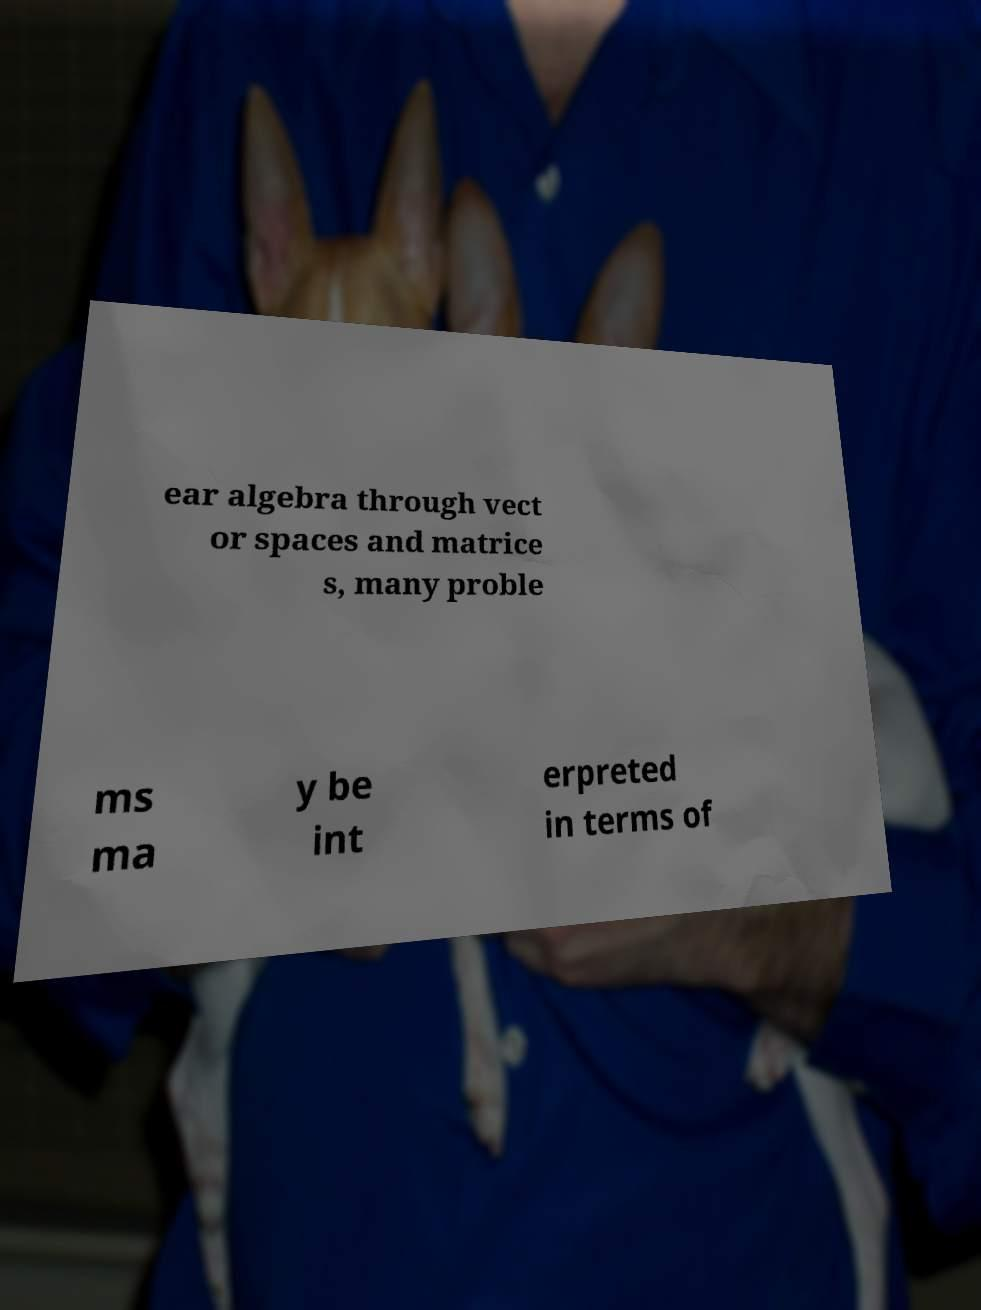What messages or text are displayed in this image? I need them in a readable, typed format. ear algebra through vect or spaces and matrice s, many proble ms ma y be int erpreted in terms of 